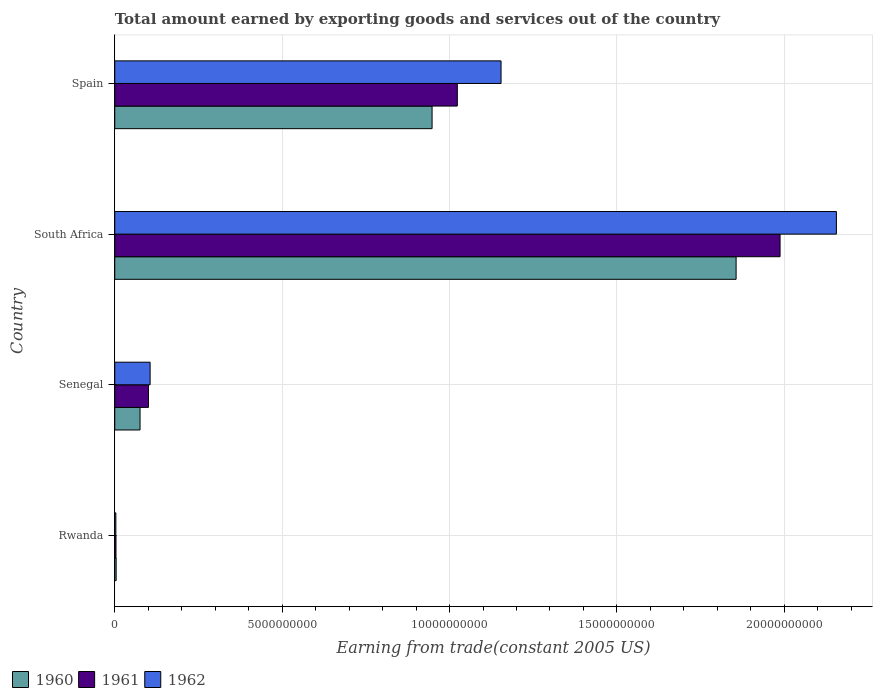How many different coloured bars are there?
Ensure brevity in your answer.  3. How many groups of bars are there?
Your answer should be very brief. 4. What is the label of the 4th group of bars from the top?
Make the answer very short. Rwanda. In how many cases, is the number of bars for a given country not equal to the number of legend labels?
Your answer should be compact. 0. What is the total amount earned by exporting goods and services in 1961 in South Africa?
Offer a terse response. 1.99e+1. Across all countries, what is the maximum total amount earned by exporting goods and services in 1961?
Provide a succinct answer. 1.99e+1. Across all countries, what is the minimum total amount earned by exporting goods and services in 1960?
Make the answer very short. 4.18e+07. In which country was the total amount earned by exporting goods and services in 1960 maximum?
Offer a very short reply. South Africa. In which country was the total amount earned by exporting goods and services in 1961 minimum?
Your answer should be very brief. Rwanda. What is the total total amount earned by exporting goods and services in 1961 in the graph?
Give a very brief answer. 3.11e+1. What is the difference between the total amount earned by exporting goods and services in 1961 in Rwanda and that in Senegal?
Offer a very short reply. -9.70e+08. What is the difference between the total amount earned by exporting goods and services in 1962 in South Africa and the total amount earned by exporting goods and services in 1961 in Senegal?
Your answer should be very brief. 2.05e+1. What is the average total amount earned by exporting goods and services in 1962 per country?
Your answer should be compact. 8.55e+09. What is the difference between the total amount earned by exporting goods and services in 1962 and total amount earned by exporting goods and services in 1961 in South Africa?
Provide a short and direct response. 1.68e+09. What is the ratio of the total amount earned by exporting goods and services in 1961 in Senegal to that in Spain?
Offer a very short reply. 0.1. What is the difference between the highest and the second highest total amount earned by exporting goods and services in 1960?
Your response must be concise. 9.08e+09. What is the difference between the highest and the lowest total amount earned by exporting goods and services in 1961?
Ensure brevity in your answer.  1.98e+1. How many countries are there in the graph?
Make the answer very short. 4. Are the values on the major ticks of X-axis written in scientific E-notation?
Provide a short and direct response. No. What is the title of the graph?
Your answer should be very brief. Total amount earned by exporting goods and services out of the country. Does "2010" appear as one of the legend labels in the graph?
Offer a very short reply. No. What is the label or title of the X-axis?
Offer a very short reply. Earning from trade(constant 2005 US). What is the label or title of the Y-axis?
Your answer should be very brief. Country. What is the Earning from trade(constant 2005 US) of 1960 in Rwanda?
Your answer should be compact. 4.18e+07. What is the Earning from trade(constant 2005 US) in 1961 in Rwanda?
Your answer should be compact. 3.69e+07. What is the Earning from trade(constant 2005 US) of 1962 in Rwanda?
Provide a succinct answer. 3.32e+07. What is the Earning from trade(constant 2005 US) in 1960 in Senegal?
Give a very brief answer. 7.56e+08. What is the Earning from trade(constant 2005 US) in 1961 in Senegal?
Ensure brevity in your answer.  1.01e+09. What is the Earning from trade(constant 2005 US) in 1962 in Senegal?
Offer a very short reply. 1.06e+09. What is the Earning from trade(constant 2005 US) of 1960 in South Africa?
Your response must be concise. 1.86e+1. What is the Earning from trade(constant 2005 US) of 1961 in South Africa?
Provide a succinct answer. 1.99e+1. What is the Earning from trade(constant 2005 US) of 1962 in South Africa?
Your answer should be compact. 2.16e+1. What is the Earning from trade(constant 2005 US) of 1960 in Spain?
Offer a very short reply. 9.48e+09. What is the Earning from trade(constant 2005 US) of 1961 in Spain?
Keep it short and to the point. 1.02e+1. What is the Earning from trade(constant 2005 US) in 1962 in Spain?
Your answer should be compact. 1.15e+1. Across all countries, what is the maximum Earning from trade(constant 2005 US) of 1960?
Your response must be concise. 1.86e+1. Across all countries, what is the maximum Earning from trade(constant 2005 US) of 1961?
Your answer should be very brief. 1.99e+1. Across all countries, what is the maximum Earning from trade(constant 2005 US) of 1962?
Make the answer very short. 2.16e+1. Across all countries, what is the minimum Earning from trade(constant 2005 US) of 1960?
Your response must be concise. 4.18e+07. Across all countries, what is the minimum Earning from trade(constant 2005 US) in 1961?
Keep it short and to the point. 3.69e+07. Across all countries, what is the minimum Earning from trade(constant 2005 US) of 1962?
Give a very brief answer. 3.32e+07. What is the total Earning from trade(constant 2005 US) in 1960 in the graph?
Provide a succinct answer. 2.88e+1. What is the total Earning from trade(constant 2005 US) of 1961 in the graph?
Provide a succinct answer. 3.11e+1. What is the total Earning from trade(constant 2005 US) of 1962 in the graph?
Make the answer very short. 3.42e+1. What is the difference between the Earning from trade(constant 2005 US) in 1960 in Rwanda and that in Senegal?
Keep it short and to the point. -7.14e+08. What is the difference between the Earning from trade(constant 2005 US) in 1961 in Rwanda and that in Senegal?
Your response must be concise. -9.70e+08. What is the difference between the Earning from trade(constant 2005 US) in 1962 in Rwanda and that in Senegal?
Your answer should be very brief. -1.02e+09. What is the difference between the Earning from trade(constant 2005 US) in 1960 in Rwanda and that in South Africa?
Your response must be concise. -1.85e+1. What is the difference between the Earning from trade(constant 2005 US) of 1961 in Rwanda and that in South Africa?
Your response must be concise. -1.98e+1. What is the difference between the Earning from trade(constant 2005 US) in 1962 in Rwanda and that in South Africa?
Provide a short and direct response. -2.15e+1. What is the difference between the Earning from trade(constant 2005 US) in 1960 in Rwanda and that in Spain?
Provide a succinct answer. -9.44e+09. What is the difference between the Earning from trade(constant 2005 US) in 1961 in Rwanda and that in Spain?
Your response must be concise. -1.02e+1. What is the difference between the Earning from trade(constant 2005 US) of 1962 in Rwanda and that in Spain?
Your answer should be compact. -1.15e+1. What is the difference between the Earning from trade(constant 2005 US) of 1960 in Senegal and that in South Africa?
Your response must be concise. -1.78e+1. What is the difference between the Earning from trade(constant 2005 US) of 1961 in Senegal and that in South Africa?
Ensure brevity in your answer.  -1.89e+1. What is the difference between the Earning from trade(constant 2005 US) of 1962 in Senegal and that in South Africa?
Give a very brief answer. -2.05e+1. What is the difference between the Earning from trade(constant 2005 US) of 1960 in Senegal and that in Spain?
Your answer should be very brief. -8.72e+09. What is the difference between the Earning from trade(constant 2005 US) of 1961 in Senegal and that in Spain?
Provide a succinct answer. -9.23e+09. What is the difference between the Earning from trade(constant 2005 US) of 1962 in Senegal and that in Spain?
Make the answer very short. -1.05e+1. What is the difference between the Earning from trade(constant 2005 US) of 1960 in South Africa and that in Spain?
Your response must be concise. 9.08e+09. What is the difference between the Earning from trade(constant 2005 US) of 1961 in South Africa and that in Spain?
Your answer should be compact. 9.64e+09. What is the difference between the Earning from trade(constant 2005 US) in 1962 in South Africa and that in Spain?
Ensure brevity in your answer.  1.00e+1. What is the difference between the Earning from trade(constant 2005 US) of 1960 in Rwanda and the Earning from trade(constant 2005 US) of 1961 in Senegal?
Give a very brief answer. -9.65e+08. What is the difference between the Earning from trade(constant 2005 US) of 1960 in Rwanda and the Earning from trade(constant 2005 US) of 1962 in Senegal?
Ensure brevity in your answer.  -1.01e+09. What is the difference between the Earning from trade(constant 2005 US) in 1961 in Rwanda and the Earning from trade(constant 2005 US) in 1962 in Senegal?
Ensure brevity in your answer.  -1.02e+09. What is the difference between the Earning from trade(constant 2005 US) of 1960 in Rwanda and the Earning from trade(constant 2005 US) of 1961 in South Africa?
Provide a short and direct response. -1.98e+1. What is the difference between the Earning from trade(constant 2005 US) in 1960 in Rwanda and the Earning from trade(constant 2005 US) in 1962 in South Africa?
Provide a short and direct response. -2.15e+1. What is the difference between the Earning from trade(constant 2005 US) in 1961 in Rwanda and the Earning from trade(constant 2005 US) in 1962 in South Africa?
Your answer should be very brief. -2.15e+1. What is the difference between the Earning from trade(constant 2005 US) in 1960 in Rwanda and the Earning from trade(constant 2005 US) in 1961 in Spain?
Your answer should be compact. -1.02e+1. What is the difference between the Earning from trade(constant 2005 US) of 1960 in Rwanda and the Earning from trade(constant 2005 US) of 1962 in Spain?
Your answer should be very brief. -1.15e+1. What is the difference between the Earning from trade(constant 2005 US) in 1961 in Rwanda and the Earning from trade(constant 2005 US) in 1962 in Spain?
Give a very brief answer. -1.15e+1. What is the difference between the Earning from trade(constant 2005 US) in 1960 in Senegal and the Earning from trade(constant 2005 US) in 1961 in South Africa?
Provide a short and direct response. -1.91e+1. What is the difference between the Earning from trade(constant 2005 US) of 1960 in Senegal and the Earning from trade(constant 2005 US) of 1962 in South Africa?
Your answer should be very brief. -2.08e+1. What is the difference between the Earning from trade(constant 2005 US) in 1961 in Senegal and the Earning from trade(constant 2005 US) in 1962 in South Africa?
Offer a very short reply. -2.05e+1. What is the difference between the Earning from trade(constant 2005 US) in 1960 in Senegal and the Earning from trade(constant 2005 US) in 1961 in Spain?
Keep it short and to the point. -9.48e+09. What is the difference between the Earning from trade(constant 2005 US) of 1960 in Senegal and the Earning from trade(constant 2005 US) of 1962 in Spain?
Give a very brief answer. -1.08e+1. What is the difference between the Earning from trade(constant 2005 US) of 1961 in Senegal and the Earning from trade(constant 2005 US) of 1962 in Spain?
Provide a succinct answer. -1.05e+1. What is the difference between the Earning from trade(constant 2005 US) in 1960 in South Africa and the Earning from trade(constant 2005 US) in 1961 in Spain?
Offer a very short reply. 8.33e+09. What is the difference between the Earning from trade(constant 2005 US) of 1960 in South Africa and the Earning from trade(constant 2005 US) of 1962 in Spain?
Offer a terse response. 7.02e+09. What is the difference between the Earning from trade(constant 2005 US) in 1961 in South Africa and the Earning from trade(constant 2005 US) in 1962 in Spain?
Provide a short and direct response. 8.33e+09. What is the average Earning from trade(constant 2005 US) in 1960 per country?
Keep it short and to the point. 7.21e+09. What is the average Earning from trade(constant 2005 US) in 1961 per country?
Your answer should be compact. 7.79e+09. What is the average Earning from trade(constant 2005 US) of 1962 per country?
Ensure brevity in your answer.  8.55e+09. What is the difference between the Earning from trade(constant 2005 US) of 1960 and Earning from trade(constant 2005 US) of 1961 in Rwanda?
Ensure brevity in your answer.  4.89e+06. What is the difference between the Earning from trade(constant 2005 US) of 1960 and Earning from trade(constant 2005 US) of 1962 in Rwanda?
Your response must be concise. 8.56e+06. What is the difference between the Earning from trade(constant 2005 US) in 1961 and Earning from trade(constant 2005 US) in 1962 in Rwanda?
Make the answer very short. 3.68e+06. What is the difference between the Earning from trade(constant 2005 US) of 1960 and Earning from trade(constant 2005 US) of 1961 in Senegal?
Give a very brief answer. -2.51e+08. What is the difference between the Earning from trade(constant 2005 US) of 1960 and Earning from trade(constant 2005 US) of 1962 in Senegal?
Make the answer very short. -3.00e+08. What is the difference between the Earning from trade(constant 2005 US) in 1961 and Earning from trade(constant 2005 US) in 1962 in Senegal?
Offer a very short reply. -4.96e+07. What is the difference between the Earning from trade(constant 2005 US) of 1960 and Earning from trade(constant 2005 US) of 1961 in South Africa?
Provide a short and direct response. -1.31e+09. What is the difference between the Earning from trade(constant 2005 US) of 1960 and Earning from trade(constant 2005 US) of 1962 in South Africa?
Your answer should be compact. -3.00e+09. What is the difference between the Earning from trade(constant 2005 US) in 1961 and Earning from trade(constant 2005 US) in 1962 in South Africa?
Your answer should be very brief. -1.68e+09. What is the difference between the Earning from trade(constant 2005 US) of 1960 and Earning from trade(constant 2005 US) of 1961 in Spain?
Keep it short and to the point. -7.54e+08. What is the difference between the Earning from trade(constant 2005 US) in 1960 and Earning from trade(constant 2005 US) in 1962 in Spain?
Give a very brief answer. -2.06e+09. What is the difference between the Earning from trade(constant 2005 US) in 1961 and Earning from trade(constant 2005 US) in 1962 in Spain?
Your answer should be very brief. -1.31e+09. What is the ratio of the Earning from trade(constant 2005 US) in 1960 in Rwanda to that in Senegal?
Ensure brevity in your answer.  0.06. What is the ratio of the Earning from trade(constant 2005 US) in 1961 in Rwanda to that in Senegal?
Offer a terse response. 0.04. What is the ratio of the Earning from trade(constant 2005 US) of 1962 in Rwanda to that in Senegal?
Your answer should be compact. 0.03. What is the ratio of the Earning from trade(constant 2005 US) of 1960 in Rwanda to that in South Africa?
Offer a very short reply. 0. What is the ratio of the Earning from trade(constant 2005 US) of 1961 in Rwanda to that in South Africa?
Your answer should be compact. 0. What is the ratio of the Earning from trade(constant 2005 US) of 1962 in Rwanda to that in South Africa?
Keep it short and to the point. 0. What is the ratio of the Earning from trade(constant 2005 US) in 1960 in Rwanda to that in Spain?
Provide a short and direct response. 0. What is the ratio of the Earning from trade(constant 2005 US) in 1961 in Rwanda to that in Spain?
Your answer should be very brief. 0. What is the ratio of the Earning from trade(constant 2005 US) of 1962 in Rwanda to that in Spain?
Offer a terse response. 0. What is the ratio of the Earning from trade(constant 2005 US) in 1960 in Senegal to that in South Africa?
Your answer should be very brief. 0.04. What is the ratio of the Earning from trade(constant 2005 US) in 1961 in Senegal to that in South Africa?
Your answer should be compact. 0.05. What is the ratio of the Earning from trade(constant 2005 US) in 1962 in Senegal to that in South Africa?
Provide a short and direct response. 0.05. What is the ratio of the Earning from trade(constant 2005 US) of 1960 in Senegal to that in Spain?
Keep it short and to the point. 0.08. What is the ratio of the Earning from trade(constant 2005 US) of 1961 in Senegal to that in Spain?
Give a very brief answer. 0.1. What is the ratio of the Earning from trade(constant 2005 US) of 1962 in Senegal to that in Spain?
Offer a very short reply. 0.09. What is the ratio of the Earning from trade(constant 2005 US) in 1960 in South Africa to that in Spain?
Provide a short and direct response. 1.96. What is the ratio of the Earning from trade(constant 2005 US) in 1961 in South Africa to that in Spain?
Offer a very short reply. 1.94. What is the ratio of the Earning from trade(constant 2005 US) in 1962 in South Africa to that in Spain?
Provide a succinct answer. 1.87. What is the difference between the highest and the second highest Earning from trade(constant 2005 US) in 1960?
Your answer should be very brief. 9.08e+09. What is the difference between the highest and the second highest Earning from trade(constant 2005 US) of 1961?
Your response must be concise. 9.64e+09. What is the difference between the highest and the second highest Earning from trade(constant 2005 US) of 1962?
Your response must be concise. 1.00e+1. What is the difference between the highest and the lowest Earning from trade(constant 2005 US) of 1960?
Your response must be concise. 1.85e+1. What is the difference between the highest and the lowest Earning from trade(constant 2005 US) of 1961?
Provide a succinct answer. 1.98e+1. What is the difference between the highest and the lowest Earning from trade(constant 2005 US) in 1962?
Provide a succinct answer. 2.15e+1. 